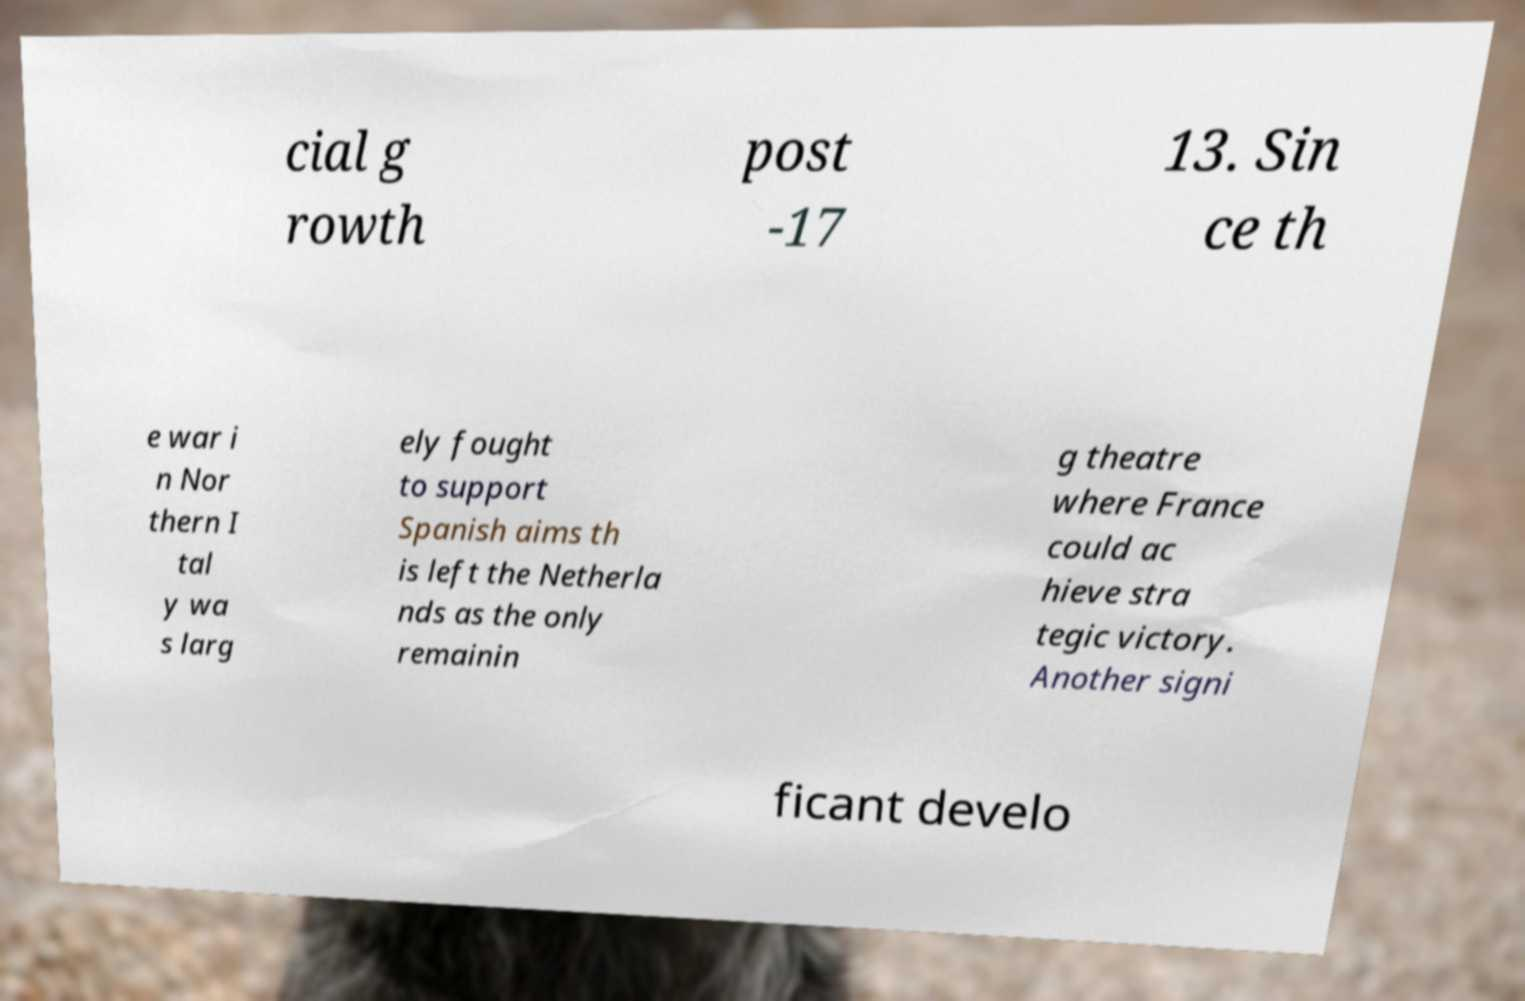For documentation purposes, I need the text within this image transcribed. Could you provide that? cial g rowth post -17 13. Sin ce th e war i n Nor thern I tal y wa s larg ely fought to support Spanish aims th is left the Netherla nds as the only remainin g theatre where France could ac hieve stra tegic victory. Another signi ficant develo 